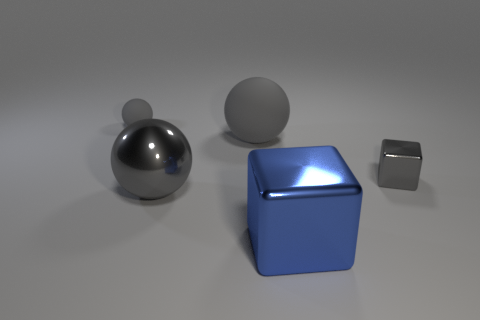What shape is the object that is both in front of the tiny gray cube and left of the large blue metal object?
Your answer should be very brief. Sphere. The gray thing to the right of the large matte sphere has what shape?
Offer a very short reply. Cube. How many matte objects are both in front of the tiny sphere and to the left of the big gray matte sphere?
Your answer should be very brief. 0. Is the size of the gray cube the same as the gray matte ball that is to the right of the tiny gray matte ball?
Offer a terse response. No. There is a sphere that is on the right side of the large gray sphere in front of the small object right of the large blue metallic block; how big is it?
Your answer should be compact. Large. How big is the shiny block right of the large blue thing?
Keep it short and to the point. Small. What shape is the large blue thing that is made of the same material as the tiny cube?
Offer a very short reply. Cube. Is the material of the small gray thing on the left side of the big matte object the same as the large blue block?
Give a very brief answer. No. What number of other objects are there of the same material as the blue block?
Your response must be concise. 2. What number of things are either spheres that are in front of the large gray matte thing or large metallic objects to the left of the large cube?
Your answer should be compact. 1. 